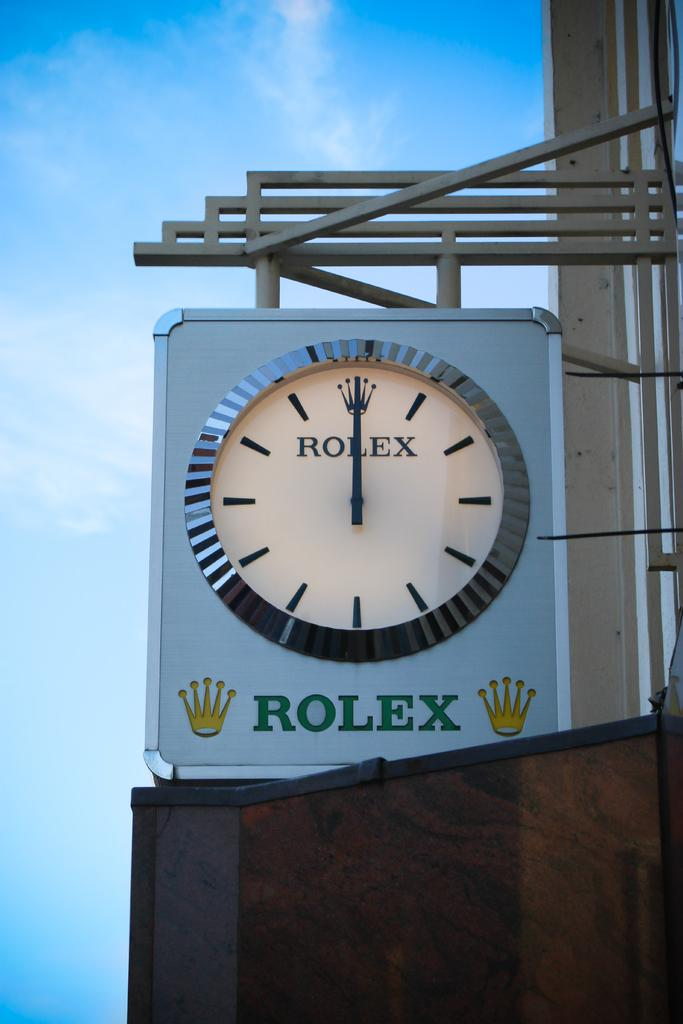Provide a one-sentence caption for the provided image. An outdoor Rolex clock shows that the time is now 12:00. 